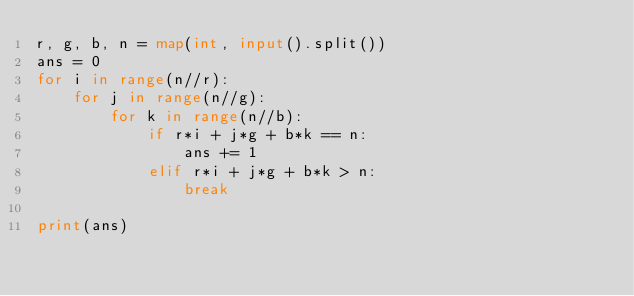Convert code to text. <code><loc_0><loc_0><loc_500><loc_500><_Python_>r, g, b, n = map(int, input().split())
ans = 0
for i in range(n//r):
    for j in range(n//g):
        for k in range(n//b):
            if r*i + j*g + b*k == n:
                ans += 1
            elif r*i + j*g + b*k > n:
                break

print(ans)</code> 